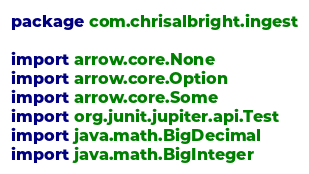<code> <loc_0><loc_0><loc_500><loc_500><_Kotlin_>package com.chrisalbright.ingest

import arrow.core.None
import arrow.core.Option
import arrow.core.Some
import org.junit.jupiter.api.Test
import java.math.BigDecimal
import java.math.BigInteger</code> 